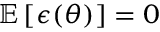Convert formula to latex. <formula><loc_0><loc_0><loc_500><loc_500>\mathbb { E } \left [ \epsilon ( \theta ) \right ] = 0</formula> 